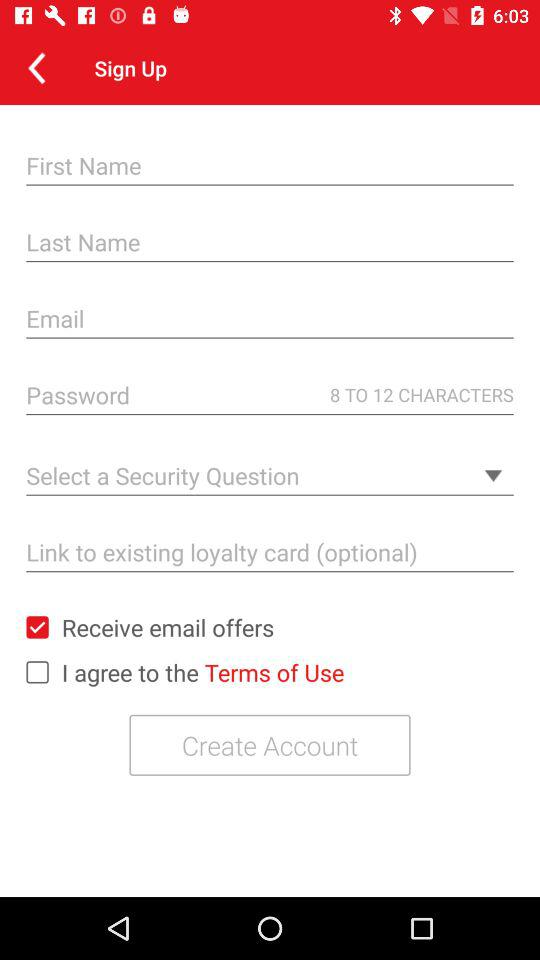What is the status of "Receive email offers"? The status of "Receive email offers" is "on". 